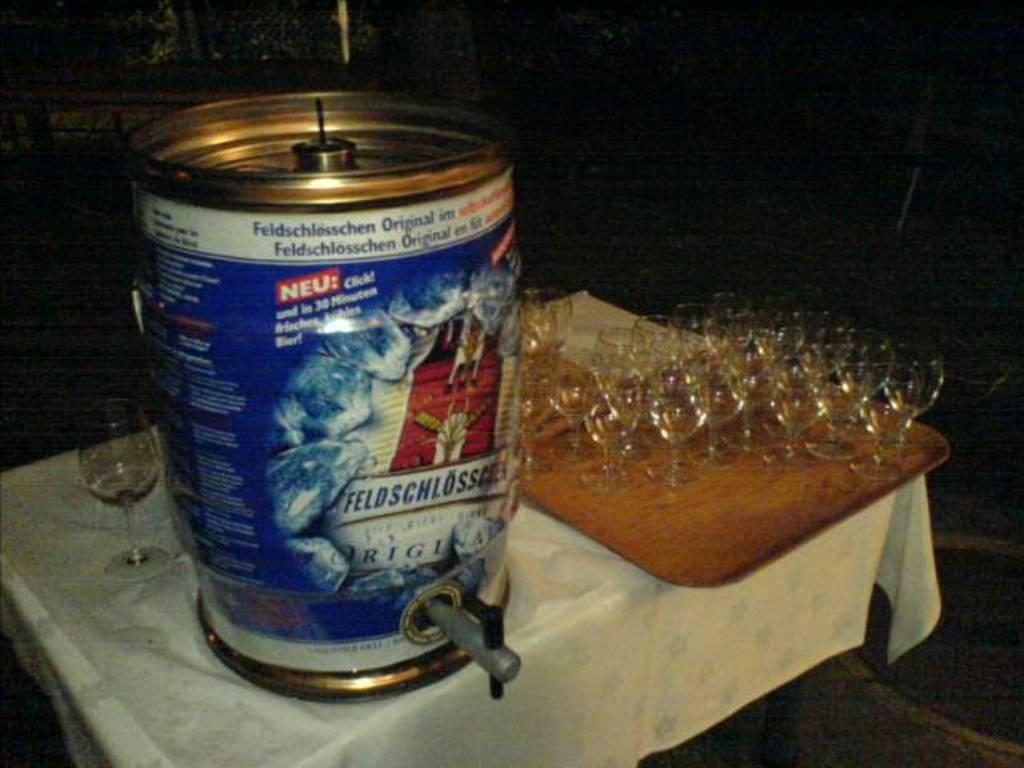<image>
Share a concise interpretation of the image provided. A keg with a "neu" and other labels in German is on the table with empty glasses on the right. 